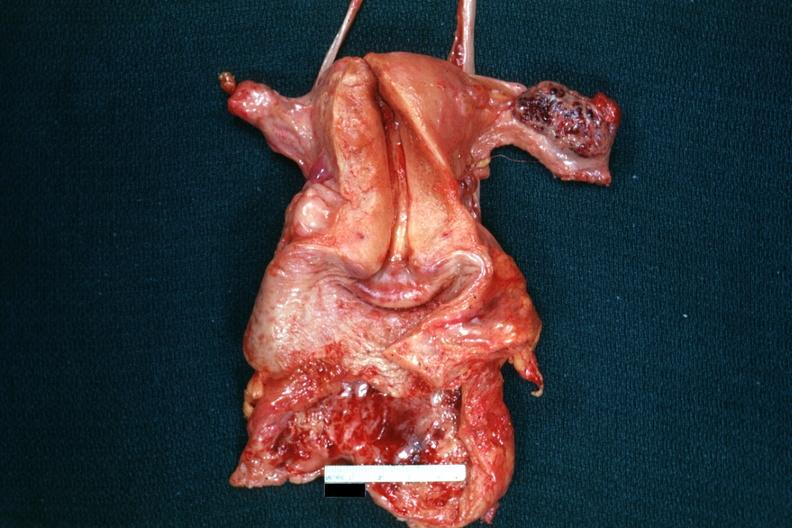s hemorrhagic corpus luteum present?
Answer the question using a single word or phrase. Yes 